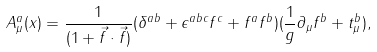<formula> <loc_0><loc_0><loc_500><loc_500>A ^ { a } _ { \mu } ( x ) = \frac { 1 } { ( 1 + \vec { f } \cdot \vec { f } ) } ( \delta ^ { a b } + \epsilon ^ { a b c } f ^ { c } + f ^ { a } f ^ { b } ) ( \frac { 1 } { g } \partial _ { \mu } f ^ { b } + t ^ { b } _ { \mu } ) ,</formula> 